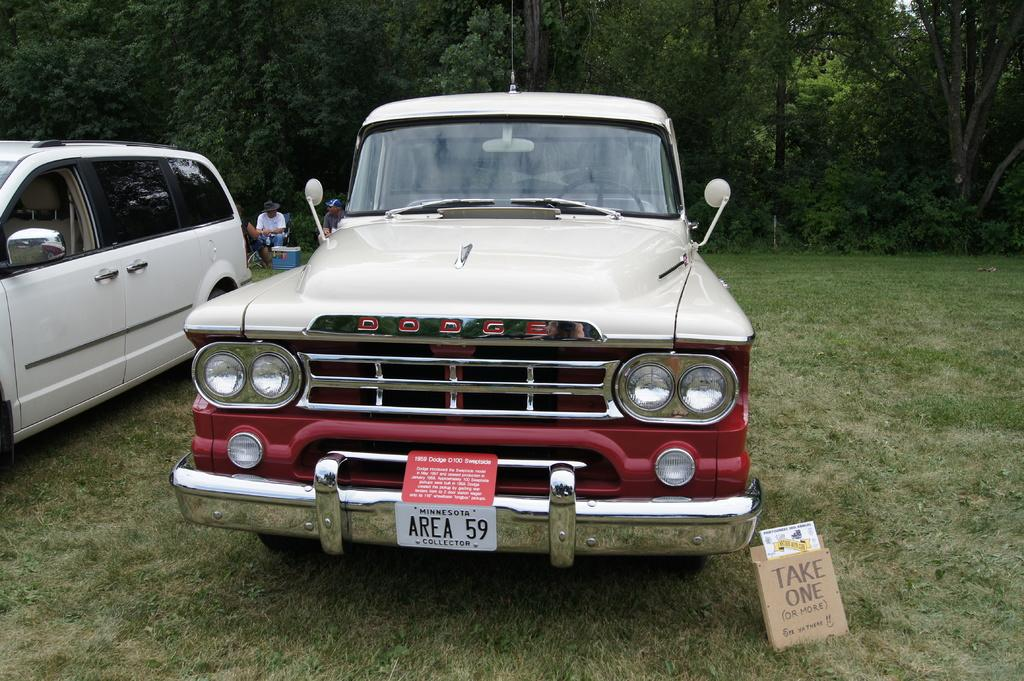What type of vehicles can be seen in the image? There are cars in the image. What object is present in the image that is not a car or a tree? There is a box in the image. What type of natural environment is visible in the image? There is grass visible in the image. Can you describe the person in the image? There is a man sitting on a chair in the image. What else can be seen in the image besides the cars and the man? There are trees in the image. What type of owl can be seen perched on the table in the image? There is no owl or table present in the image. What type of harmony is being displayed by the people in the image? There are no people present in the image, so it is not possible to determine any harmony being displayed. 